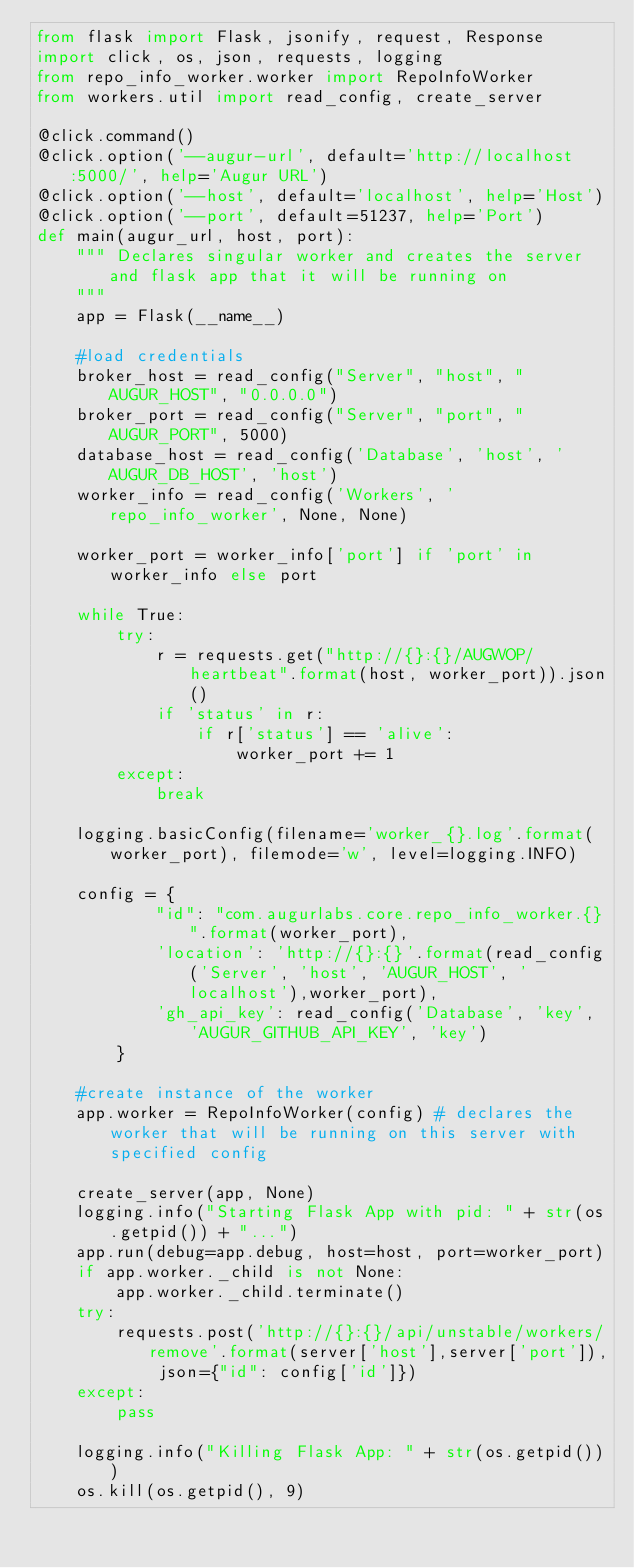Convert code to text. <code><loc_0><loc_0><loc_500><loc_500><_Python_>from flask import Flask, jsonify, request, Response
import click, os, json, requests, logging
from repo_info_worker.worker import RepoInfoWorker
from workers.util import read_config, create_server

@click.command()
@click.option('--augur-url', default='http://localhost:5000/', help='Augur URL')
@click.option('--host', default='localhost', help='Host')
@click.option('--port', default=51237, help='Port')
def main(augur_url, host, port):
    """ Declares singular worker and creates the server and flask app that it will be running on
    """
    app = Flask(__name__)

    #load credentials
    broker_host = read_config("Server", "host", "AUGUR_HOST", "0.0.0.0")
    broker_port = read_config("Server", "port", "AUGUR_PORT", 5000)
    database_host = read_config('Database', 'host', 'AUGUR_DB_HOST', 'host')
    worker_info = read_config('Workers', 'repo_info_worker', None, None)

    worker_port = worker_info['port'] if 'port' in worker_info else port

    while True:
        try:
            r = requests.get("http://{}:{}/AUGWOP/heartbeat".format(host, worker_port)).json()
            if 'status' in r:
                if r['status'] == 'alive':
                    worker_port += 1
        except:
            break

    logging.basicConfig(filename='worker_{}.log'.format(worker_port), filemode='w', level=logging.INFO)

    config = { 
            "id": "com.augurlabs.core.repo_info_worker.{}".format(worker_port),
            'location': 'http://{}:{}'.format(read_config('Server', 'host', 'AUGUR_HOST', 'localhost'),worker_port),
            'gh_api_key': read_config('Database', 'key', 'AUGUR_GITHUB_API_KEY', 'key')
        }

    #create instance of the worker
    app.worker = RepoInfoWorker(config) # declares the worker that will be running on this server with specified config

    create_server(app, None)
    logging.info("Starting Flask App with pid: " + str(os.getpid()) + "...")
    app.run(debug=app.debug, host=host, port=worker_port)
    if app.worker._child is not None:
        app.worker._child.terminate()
    try:
        requests.post('http://{}:{}/api/unstable/workers/remove'.format(server['host'],server['port']), json={"id": config['id']})
    except:
        pass

    logging.info("Killing Flask App: " + str(os.getpid()))
    os.kill(os.getpid(), 9)

</code> 